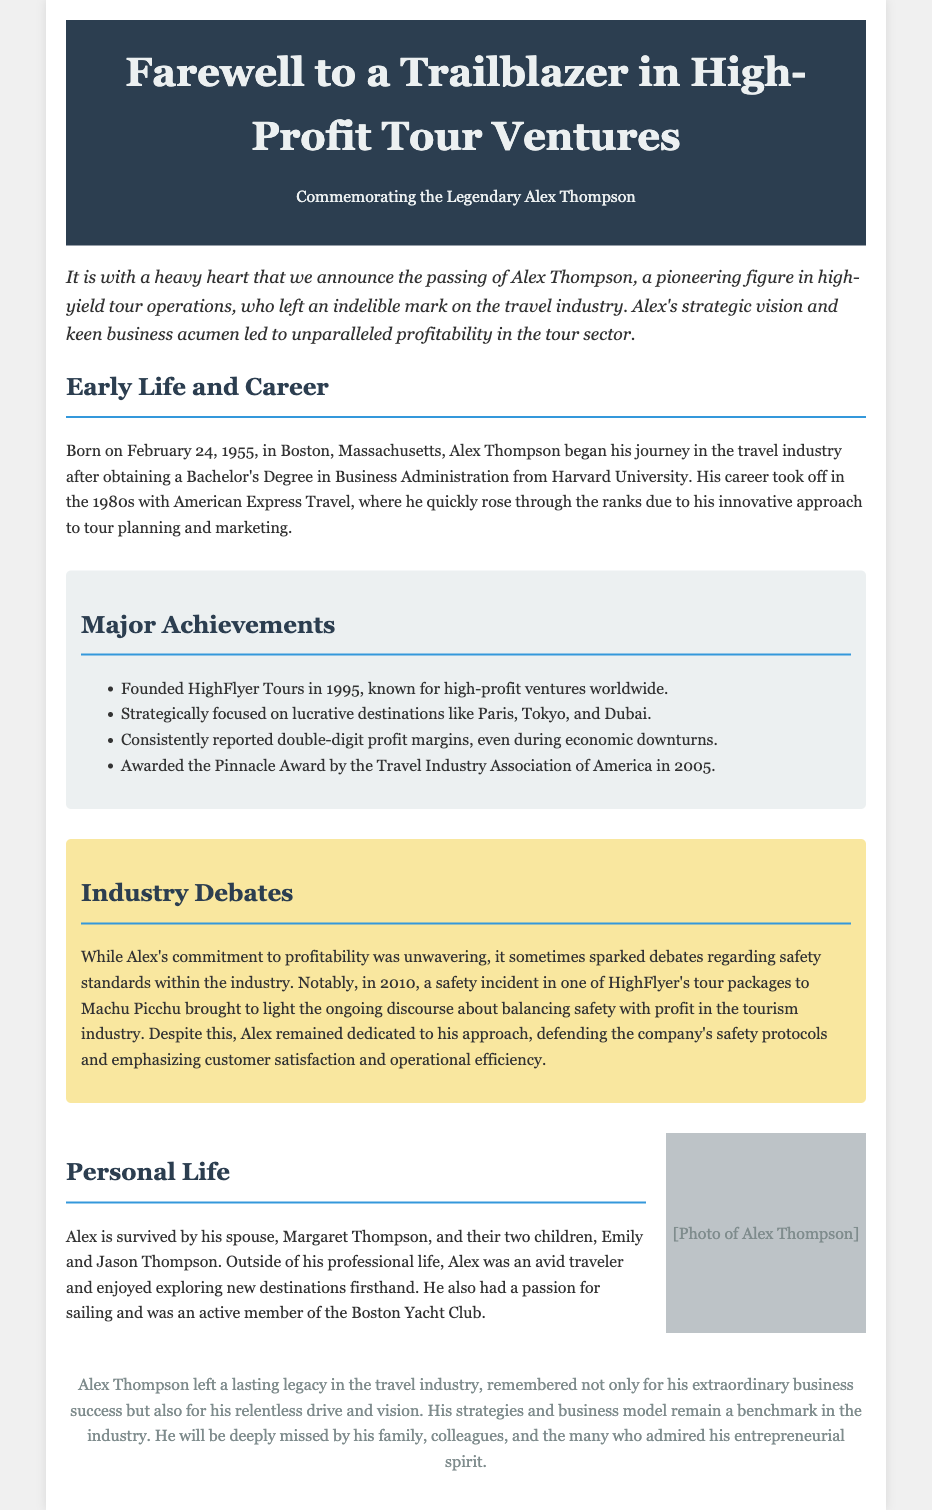What is the name of the trailblazer commemorated in the obituary? The obituary commemorates Alex Thompson, a pioneering figure in high-yield tour operations.
Answer: Alex Thompson When was Alex Thompson born? Alex Thompson was born on February 24, 1955.
Answer: February 24, 1955 What company did Alex Thompson found in 1995? Alex Thompson founded HighFlyer Tours in 1995, known for high-profit ventures worldwide.
Answer: HighFlyer Tours Which award did Alex Thompson receive in 2005? Alex Thompson was awarded the Pinnacle Award by the Travel Industry Association of America in 2005.
Answer: Pinnacle Award What was one of the controversial topics linked to Alex's business practices? Alex's business practices sparked debates regarding safety standards within the industry.
Answer: Safety standards What did Alex emphasize in defending his company's practices? Alex emphasized customer satisfaction and operational efficiency in his defense.
Answer: Customer satisfaction and operational efficiency How many children did Alex Thompson have? Alex Thompson had two children, Emily and Jason Thompson.
Answer: Two What was Alex's profession before his major tour company? Alex worked at American Express Travel in the 1980s.
Answer: American Express Travel Which sport was Alex Thompson passionate about? Alex Thompson had a passion for sailing.
Answer: Sailing 